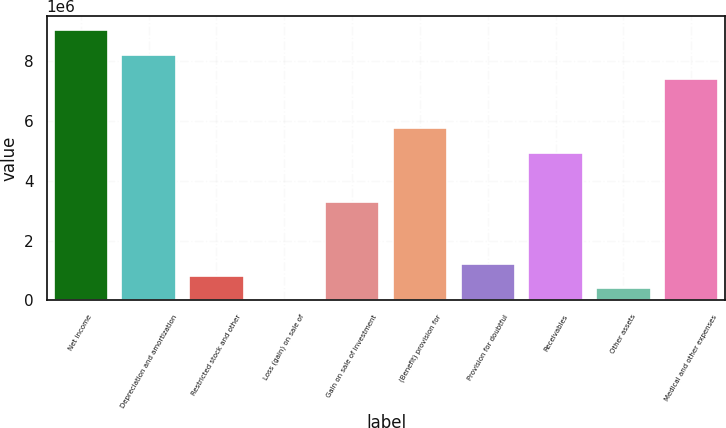Convert chart to OTSL. <chart><loc_0><loc_0><loc_500><loc_500><bar_chart><fcel>Net income<fcel>Depreciation and amortization<fcel>Restricted stock and other<fcel>Loss (gain) on sale of<fcel>Gain on sale of investment<fcel>(Benefit) provision for<fcel>Provision for doubtful<fcel>Receivables<fcel>Other assets<fcel>Medical and other expenses<nl><fcel>9.03254e+06<fcel>8.21148e+06<fcel>821990<fcel>935<fcel>3.28516e+06<fcel>5.74832e+06<fcel>1.23252e+06<fcel>4.92726e+06<fcel>411462<fcel>7.39043e+06<nl></chart> 